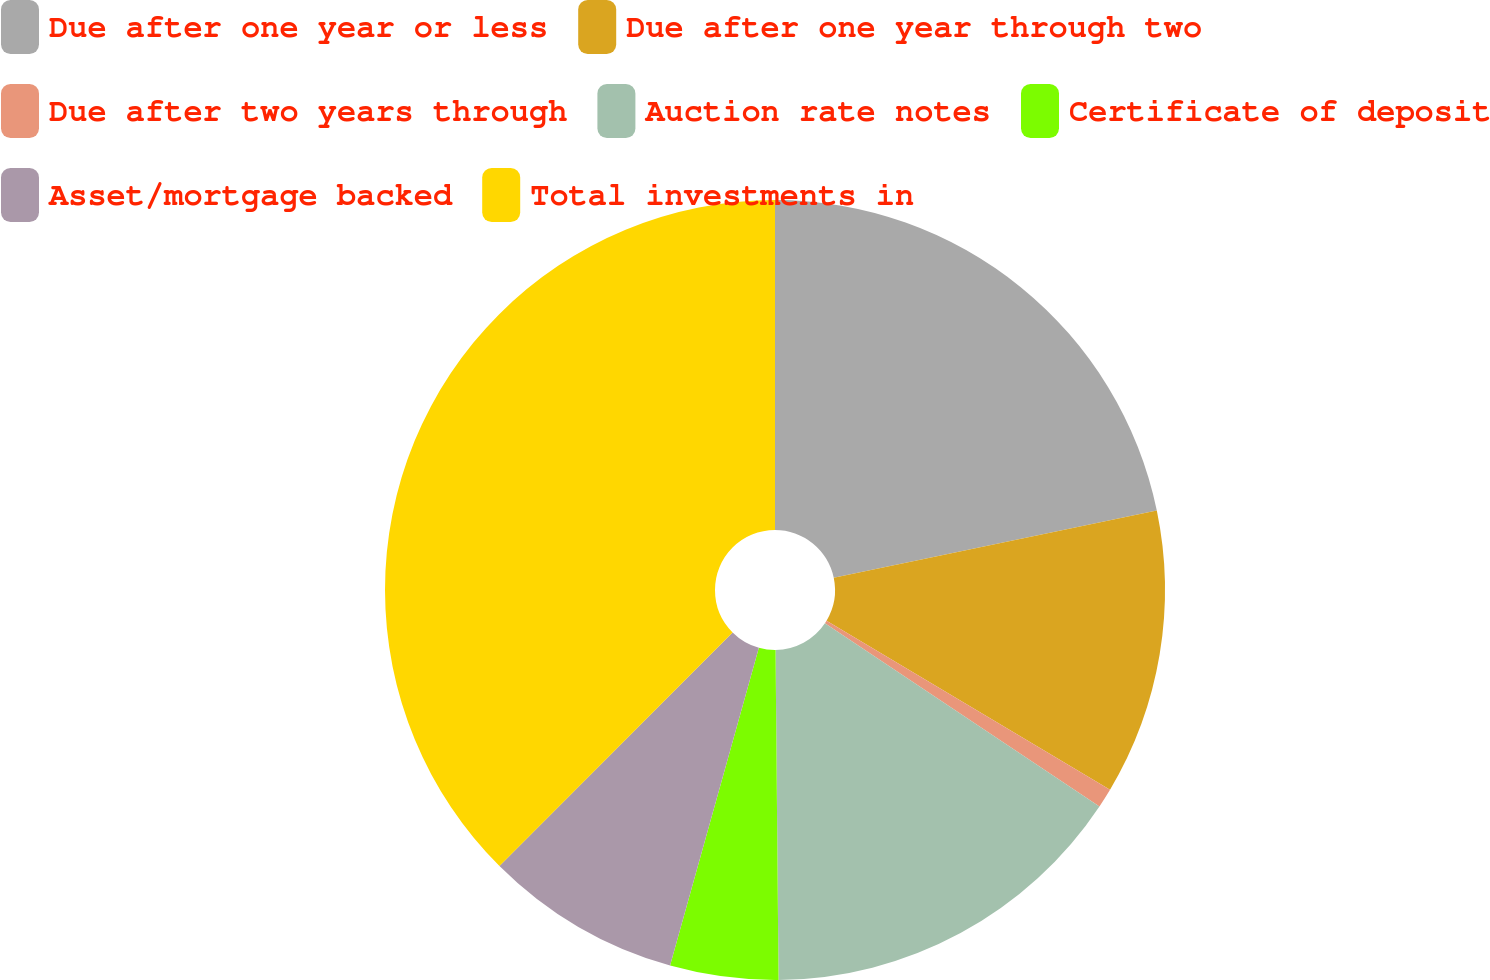<chart> <loc_0><loc_0><loc_500><loc_500><pie_chart><fcel>Due after one year or less<fcel>Due after one year through two<fcel>Due after two years through<fcel>Auction rate notes<fcel>Certificate of deposit<fcel>Asset/mortgage backed<fcel>Total investments in<nl><fcel>21.73%<fcel>11.82%<fcel>0.81%<fcel>15.49%<fcel>4.48%<fcel>8.15%<fcel>37.51%<nl></chart> 